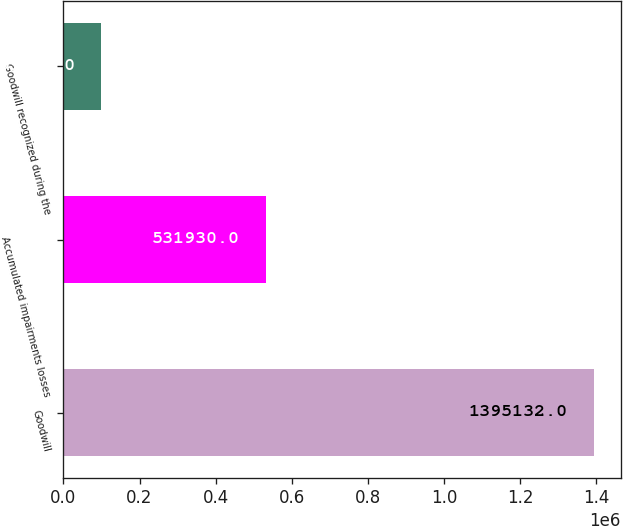<chart> <loc_0><loc_0><loc_500><loc_500><bar_chart><fcel>Goodwill<fcel>Accumulated impairments losses<fcel>Goodwill recognized during the<nl><fcel>1.39513e+06<fcel>531930<fcel>99848<nl></chart> 